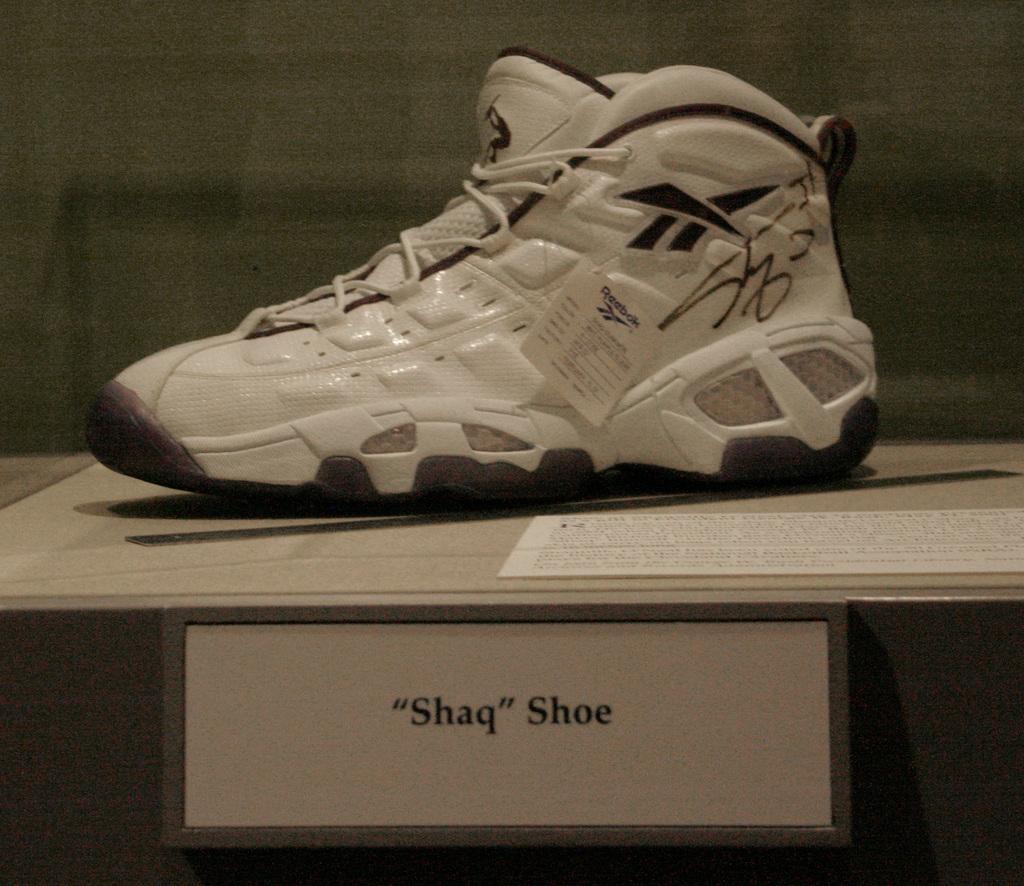Describe this image in one or two sentences. In this image we can see a shoe and a paper beside the shoe on the table and there is a board with text to the table and wall in the background. 